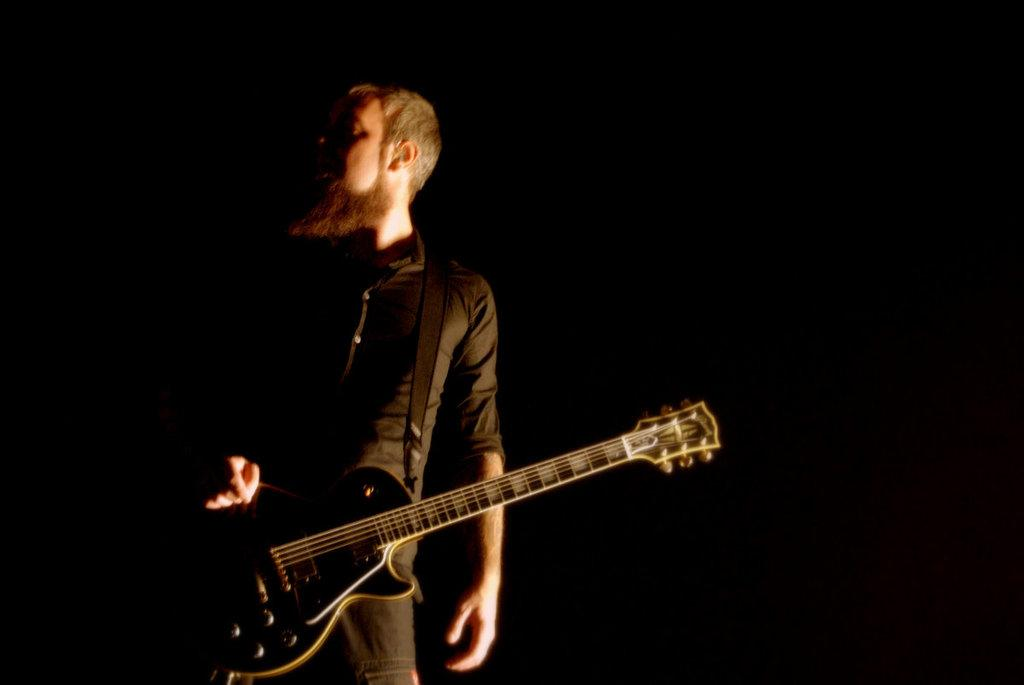What is the main subject of the image? There is a person in the image. What is the person holding in the image? The person is holding a guitar. What type of dust can be seen on the guitar strings in the image? There is no dust visible on the guitar strings in the image, as the guitar appears to be clean. 